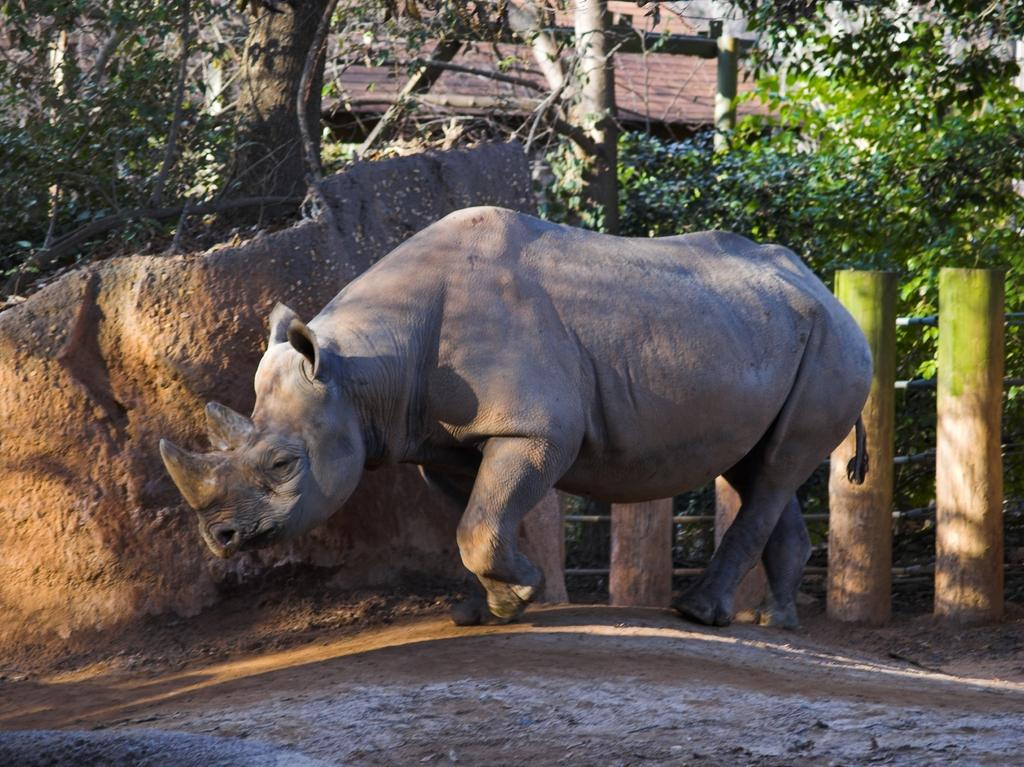What type of surface is visible in the image? There is ground visible in the image. What kind of living creature can be seen in the image? There is an animal in the image. Can you describe the color of the animal? The animal is grey and brown in color. Where is the animal positioned in the image? The animal is standing on the ground. What can be seen in the background of the image? There are wooden logs, trees, and a house in the background of the image. What type of winter clothing is the mother wearing in the image? There is no mother or winter clothing present in the image; it features an animal standing on the ground with a background of wooden logs, trees, and a house. 